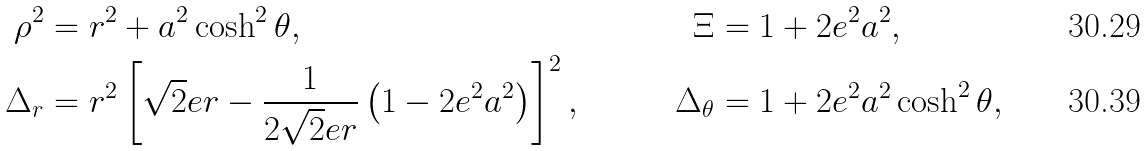Convert formula to latex. <formula><loc_0><loc_0><loc_500><loc_500>\rho ^ { 2 } & = r ^ { 2 } + a ^ { 2 } \cosh ^ { 2 } \theta , & \quad \Xi & = 1 + 2 e ^ { 2 } a ^ { 2 } , \\ \Delta _ { r } & = r ^ { 2 } \left [ \sqrt { 2 } e r - \frac { 1 } { 2 \sqrt { 2 } e r } \left ( 1 - 2 e ^ { 2 } a ^ { 2 } \right ) \right ] ^ { 2 } , & \quad \Delta _ { \theta } & = 1 + 2 e ^ { 2 } a ^ { 2 } \cosh ^ { 2 } \theta ,</formula> 